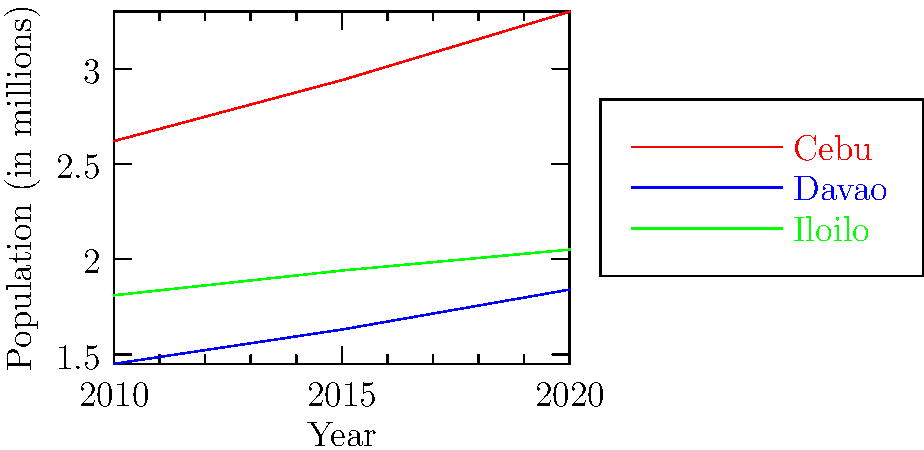Based on the line graph showing population growth in three Philippine provinces from 2010 to 2020, which province has consistently maintained the highest population growth rate, potentially requiring more resources and attention for infrastructure development? To determine which province has consistently maintained the highest population growth rate, we need to analyze the slopes of the lines for each province:

1. Cebu (red line):
   - 2010-2015: (2.94 - 2.62) / 5 = 0.064 million/year
   - 2015-2020: (3.30 - 2.94) / 5 = 0.072 million/year

2. Davao (blue line):
   - 2010-2015: (1.63 - 1.45) / 5 = 0.036 million/year
   - 2015-2020: (1.84 - 1.63) / 5 = 0.042 million/year

3. Iloilo (green line):
   - 2010-2015: (1.94 - 1.81) / 5 = 0.026 million/year
   - 2015-2020: (2.05 - 1.94) / 5 = 0.022 million/year

Cebu has the steepest slope throughout the entire period, indicating the highest and most consistent population growth rate among the three provinces.

As a conservative politician, this information is crucial for resource allocation and infrastructure planning, as Cebu's rapid growth may require more attention and investment to maintain quality of life and economic development.
Answer: Cebu 